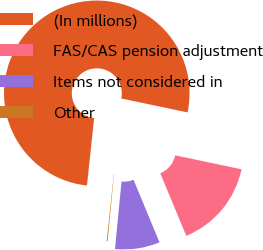<chart> <loc_0><loc_0><loc_500><loc_500><pie_chart><fcel>(In millions)<fcel>FAS/CAS pension adjustment<fcel>Items not considered in<fcel>Other<nl><fcel>76.61%<fcel>15.44%<fcel>7.8%<fcel>0.15%<nl></chart> 